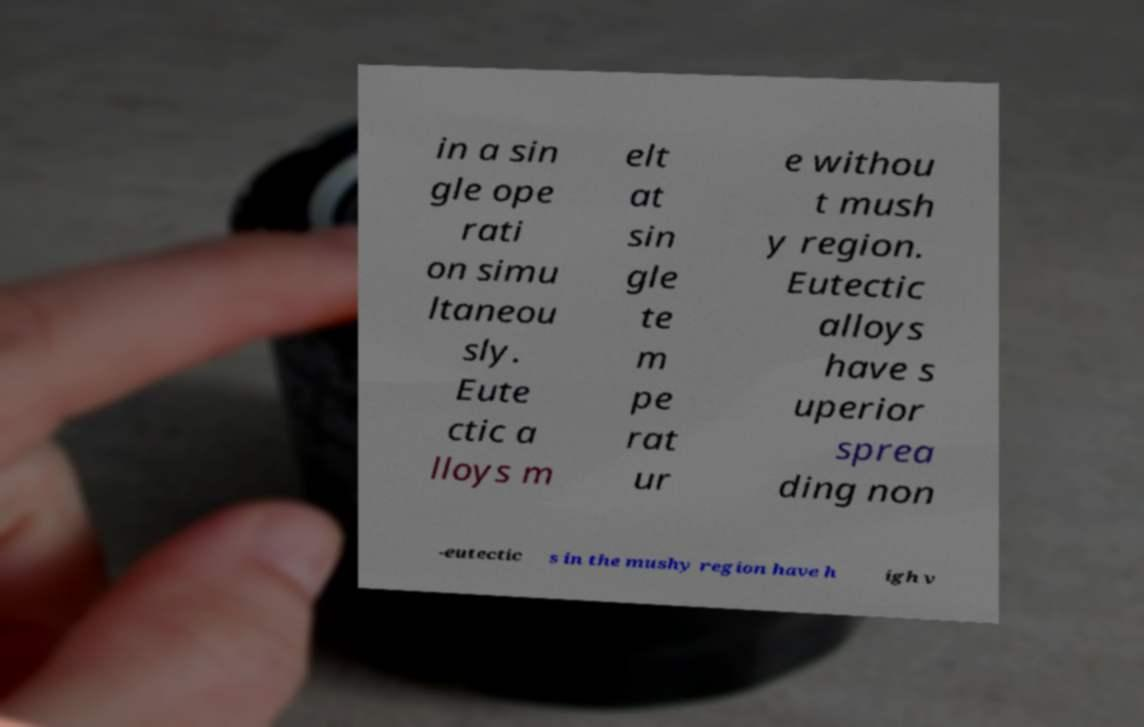Can you read and provide the text displayed in the image?This photo seems to have some interesting text. Can you extract and type it out for me? in a sin gle ope rati on simu ltaneou sly. Eute ctic a lloys m elt at sin gle te m pe rat ur e withou t mush y region. Eutectic alloys have s uperior sprea ding non -eutectic s in the mushy region have h igh v 